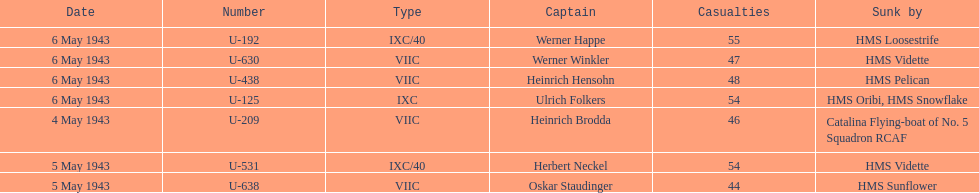What is the only vessel to sink multiple u-boats? HMS Vidette. 